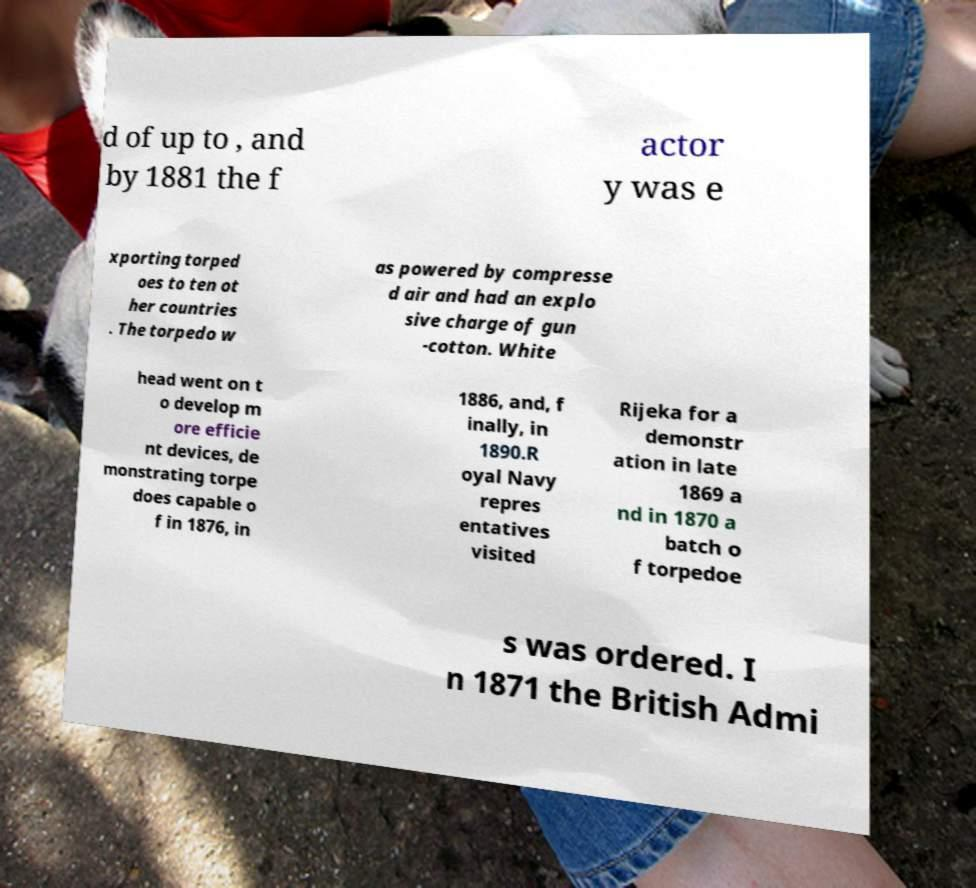For documentation purposes, I need the text within this image transcribed. Could you provide that? d of up to , and by 1881 the f actor y was e xporting torped oes to ten ot her countries . The torpedo w as powered by compresse d air and had an explo sive charge of gun -cotton. White head went on t o develop m ore efficie nt devices, de monstrating torpe does capable o f in 1876, in 1886, and, f inally, in 1890.R oyal Navy repres entatives visited Rijeka for a demonstr ation in late 1869 a nd in 1870 a batch o f torpedoe s was ordered. I n 1871 the British Admi 